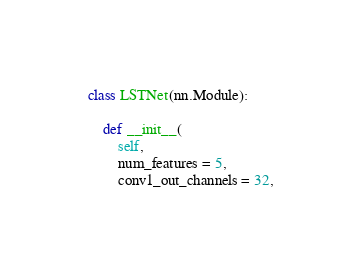<code> <loc_0><loc_0><loc_500><loc_500><_Python_>class LSTNet(nn.Module):
    
    def __init__(
        self,
        num_features = 5,
        conv1_out_channels = 32,</code> 